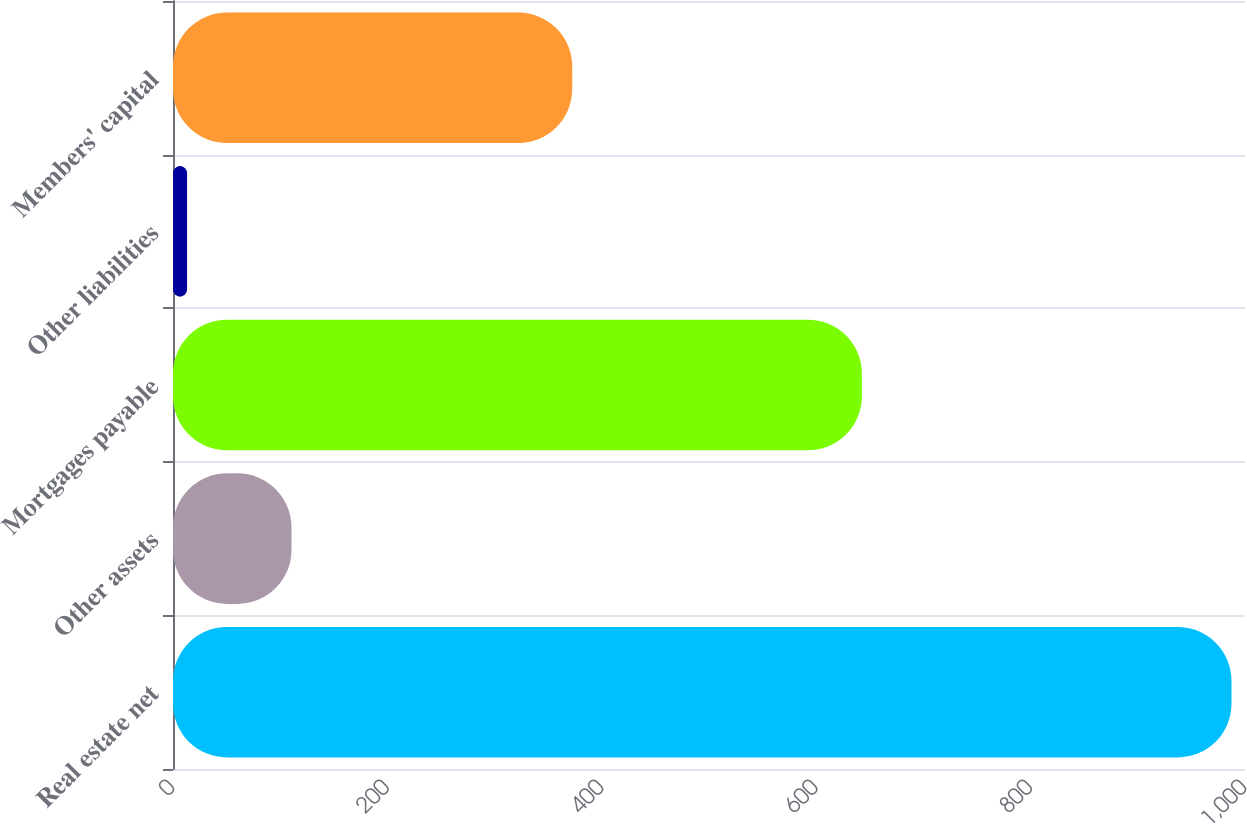Convert chart. <chart><loc_0><loc_0><loc_500><loc_500><bar_chart><fcel>Real estate net<fcel>Other assets<fcel>Mortgages payable<fcel>Other liabilities<fcel>Members' capital<nl><fcel>987.4<fcel>110.53<fcel>642.6<fcel>13.1<fcel>372.4<nl></chart> 